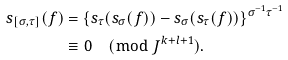<formula> <loc_0><loc_0><loc_500><loc_500>s _ { [ \sigma , \tau ] } ( f ) & = \{ s _ { \tau } ( s _ { \sigma } ( f ) ) - s _ { \sigma } ( s _ { \tau } ( f ) ) \} ^ { \sigma ^ { - 1 } \tau ^ { - 1 } } \\ & \equiv 0 \pmod { J ^ { k + l + 1 } } . \\</formula> 